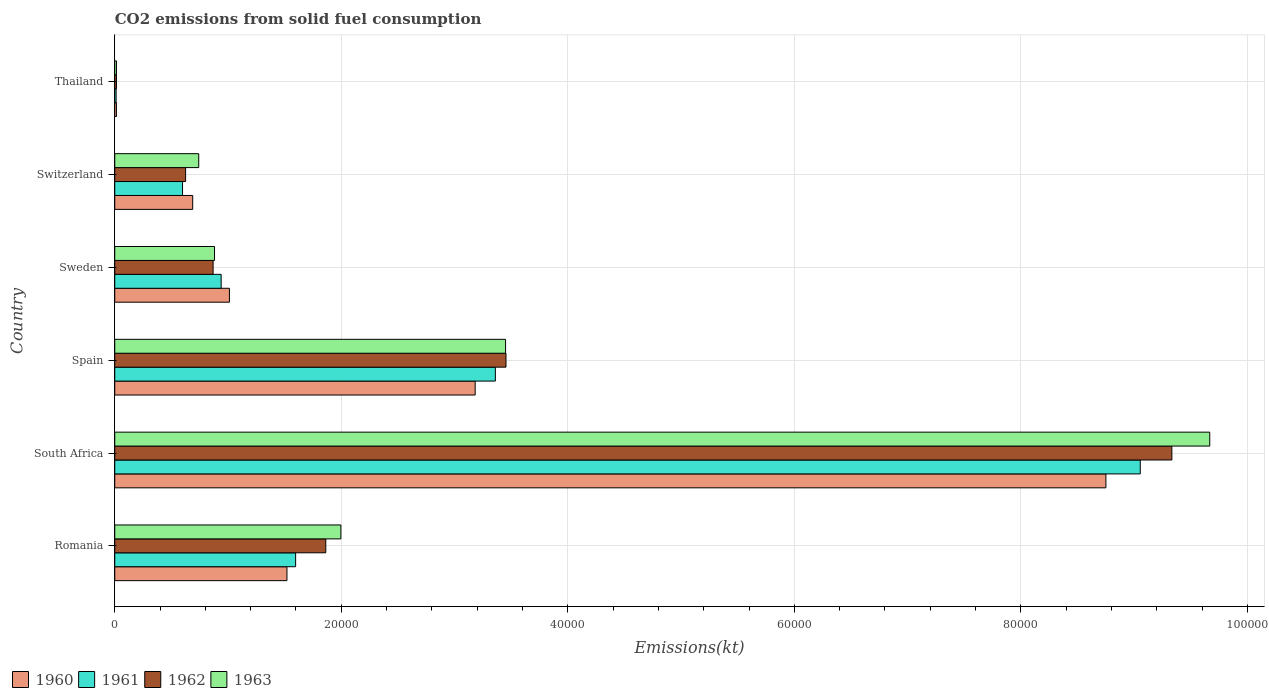How many different coloured bars are there?
Provide a short and direct response. 4. How many bars are there on the 3rd tick from the bottom?
Ensure brevity in your answer.  4. What is the label of the 5th group of bars from the top?
Offer a very short reply. South Africa. What is the amount of CO2 emitted in 1960 in South Africa?
Your response must be concise. 8.75e+04. Across all countries, what is the maximum amount of CO2 emitted in 1962?
Your response must be concise. 9.33e+04. Across all countries, what is the minimum amount of CO2 emitted in 1960?
Your answer should be very brief. 146.68. In which country was the amount of CO2 emitted in 1962 maximum?
Ensure brevity in your answer.  South Africa. In which country was the amount of CO2 emitted in 1960 minimum?
Your answer should be very brief. Thailand. What is the total amount of CO2 emitted in 1962 in the graph?
Your response must be concise. 1.62e+05. What is the difference between the amount of CO2 emitted in 1962 in Sweden and that in Switzerland?
Your response must be concise. 2427.55. What is the difference between the amount of CO2 emitted in 1960 in Romania and the amount of CO2 emitted in 1961 in Spain?
Give a very brief answer. -1.84e+04. What is the average amount of CO2 emitted in 1962 per country?
Provide a succinct answer. 2.69e+04. What is the difference between the amount of CO2 emitted in 1962 and amount of CO2 emitted in 1961 in Sweden?
Your answer should be compact. -711.4. In how many countries, is the amount of CO2 emitted in 1961 greater than 68000 kt?
Keep it short and to the point. 1. What is the ratio of the amount of CO2 emitted in 1961 in Romania to that in Spain?
Give a very brief answer. 0.48. Is the amount of CO2 emitted in 1963 in Sweden less than that in Switzerland?
Your answer should be compact. No. What is the difference between the highest and the second highest amount of CO2 emitted in 1960?
Ensure brevity in your answer.  5.57e+04. What is the difference between the highest and the lowest amount of CO2 emitted in 1963?
Make the answer very short. 9.65e+04. In how many countries, is the amount of CO2 emitted in 1961 greater than the average amount of CO2 emitted in 1961 taken over all countries?
Ensure brevity in your answer.  2. What does the 3rd bar from the top in Sweden represents?
Offer a very short reply. 1961. Is it the case that in every country, the sum of the amount of CO2 emitted in 1963 and amount of CO2 emitted in 1960 is greater than the amount of CO2 emitted in 1962?
Your answer should be very brief. Yes. What is the difference between two consecutive major ticks on the X-axis?
Provide a short and direct response. 2.00e+04. Are the values on the major ticks of X-axis written in scientific E-notation?
Give a very brief answer. No. How many legend labels are there?
Provide a succinct answer. 4. How are the legend labels stacked?
Your response must be concise. Horizontal. What is the title of the graph?
Offer a very short reply. CO2 emissions from solid fuel consumption. Does "2006" appear as one of the legend labels in the graph?
Your answer should be compact. No. What is the label or title of the X-axis?
Provide a succinct answer. Emissions(kt). What is the label or title of the Y-axis?
Make the answer very short. Country. What is the Emissions(kt) in 1960 in Romania?
Provide a short and direct response. 1.52e+04. What is the Emissions(kt) in 1961 in Romania?
Offer a terse response. 1.60e+04. What is the Emissions(kt) of 1962 in Romania?
Offer a very short reply. 1.86e+04. What is the Emissions(kt) of 1963 in Romania?
Provide a short and direct response. 2.00e+04. What is the Emissions(kt) in 1960 in South Africa?
Your response must be concise. 8.75e+04. What is the Emissions(kt) in 1961 in South Africa?
Offer a terse response. 9.05e+04. What is the Emissions(kt) in 1962 in South Africa?
Make the answer very short. 9.33e+04. What is the Emissions(kt) of 1963 in South Africa?
Provide a succinct answer. 9.67e+04. What is the Emissions(kt) of 1960 in Spain?
Your response must be concise. 3.18e+04. What is the Emissions(kt) in 1961 in Spain?
Keep it short and to the point. 3.36e+04. What is the Emissions(kt) of 1962 in Spain?
Offer a terse response. 3.45e+04. What is the Emissions(kt) in 1963 in Spain?
Your answer should be very brief. 3.45e+04. What is the Emissions(kt) in 1960 in Sweden?
Your answer should be very brief. 1.01e+04. What is the Emissions(kt) in 1961 in Sweden?
Provide a short and direct response. 9394.85. What is the Emissions(kt) in 1962 in Sweden?
Offer a very short reply. 8683.46. What is the Emissions(kt) of 1963 in Sweden?
Make the answer very short. 8808.13. What is the Emissions(kt) in 1960 in Switzerland?
Your response must be concise. 6882.96. What is the Emissions(kt) in 1961 in Switzerland?
Give a very brief answer. 5984.54. What is the Emissions(kt) in 1962 in Switzerland?
Offer a terse response. 6255.9. What is the Emissions(kt) in 1963 in Switzerland?
Provide a short and direct response. 7414.67. What is the Emissions(kt) of 1960 in Thailand?
Offer a very short reply. 146.68. What is the Emissions(kt) of 1961 in Thailand?
Your answer should be very brief. 121.01. What is the Emissions(kt) in 1962 in Thailand?
Provide a succinct answer. 150.35. What is the Emissions(kt) in 1963 in Thailand?
Provide a short and direct response. 150.35. Across all countries, what is the maximum Emissions(kt) in 1960?
Give a very brief answer. 8.75e+04. Across all countries, what is the maximum Emissions(kt) of 1961?
Give a very brief answer. 9.05e+04. Across all countries, what is the maximum Emissions(kt) in 1962?
Give a very brief answer. 9.33e+04. Across all countries, what is the maximum Emissions(kt) in 1963?
Keep it short and to the point. 9.67e+04. Across all countries, what is the minimum Emissions(kt) in 1960?
Give a very brief answer. 146.68. Across all countries, what is the minimum Emissions(kt) in 1961?
Offer a terse response. 121.01. Across all countries, what is the minimum Emissions(kt) of 1962?
Offer a very short reply. 150.35. Across all countries, what is the minimum Emissions(kt) in 1963?
Ensure brevity in your answer.  150.35. What is the total Emissions(kt) in 1960 in the graph?
Provide a succinct answer. 1.52e+05. What is the total Emissions(kt) in 1961 in the graph?
Keep it short and to the point. 1.56e+05. What is the total Emissions(kt) in 1962 in the graph?
Give a very brief answer. 1.62e+05. What is the total Emissions(kt) in 1963 in the graph?
Your answer should be very brief. 1.68e+05. What is the difference between the Emissions(kt) of 1960 in Romania and that in South Africa?
Provide a succinct answer. -7.23e+04. What is the difference between the Emissions(kt) in 1961 in Romania and that in South Africa?
Your answer should be very brief. -7.46e+04. What is the difference between the Emissions(kt) of 1962 in Romania and that in South Africa?
Offer a terse response. -7.47e+04. What is the difference between the Emissions(kt) of 1963 in Romania and that in South Africa?
Provide a short and direct response. -7.67e+04. What is the difference between the Emissions(kt) in 1960 in Romania and that in Spain?
Keep it short and to the point. -1.66e+04. What is the difference between the Emissions(kt) of 1961 in Romania and that in Spain?
Give a very brief answer. -1.76e+04. What is the difference between the Emissions(kt) in 1962 in Romania and that in Spain?
Provide a short and direct response. -1.59e+04. What is the difference between the Emissions(kt) of 1963 in Romania and that in Spain?
Provide a short and direct response. -1.45e+04. What is the difference between the Emissions(kt) of 1960 in Romania and that in Sweden?
Make the answer very short. 5078.8. What is the difference between the Emissions(kt) of 1961 in Romania and that in Sweden?
Your answer should be very brief. 6574.93. What is the difference between the Emissions(kt) of 1962 in Romania and that in Sweden?
Offer a very short reply. 9948.57. What is the difference between the Emissions(kt) in 1963 in Romania and that in Sweden?
Offer a very short reply. 1.12e+04. What is the difference between the Emissions(kt) of 1960 in Romania and that in Switzerland?
Ensure brevity in your answer.  8320.42. What is the difference between the Emissions(kt) of 1961 in Romania and that in Switzerland?
Make the answer very short. 9985.24. What is the difference between the Emissions(kt) in 1962 in Romania and that in Switzerland?
Give a very brief answer. 1.24e+04. What is the difference between the Emissions(kt) of 1963 in Romania and that in Switzerland?
Make the answer very short. 1.26e+04. What is the difference between the Emissions(kt) of 1960 in Romania and that in Thailand?
Your answer should be very brief. 1.51e+04. What is the difference between the Emissions(kt) of 1961 in Romania and that in Thailand?
Your answer should be compact. 1.58e+04. What is the difference between the Emissions(kt) of 1962 in Romania and that in Thailand?
Give a very brief answer. 1.85e+04. What is the difference between the Emissions(kt) of 1963 in Romania and that in Thailand?
Keep it short and to the point. 1.98e+04. What is the difference between the Emissions(kt) in 1960 in South Africa and that in Spain?
Your answer should be compact. 5.57e+04. What is the difference between the Emissions(kt) of 1961 in South Africa and that in Spain?
Your answer should be very brief. 5.69e+04. What is the difference between the Emissions(kt) in 1962 in South Africa and that in Spain?
Offer a terse response. 5.88e+04. What is the difference between the Emissions(kt) of 1963 in South Africa and that in Spain?
Your answer should be compact. 6.22e+04. What is the difference between the Emissions(kt) of 1960 in South Africa and that in Sweden?
Offer a terse response. 7.74e+04. What is the difference between the Emissions(kt) in 1961 in South Africa and that in Sweden?
Provide a succinct answer. 8.12e+04. What is the difference between the Emissions(kt) in 1962 in South Africa and that in Sweden?
Make the answer very short. 8.47e+04. What is the difference between the Emissions(kt) in 1963 in South Africa and that in Sweden?
Give a very brief answer. 8.79e+04. What is the difference between the Emissions(kt) in 1960 in South Africa and that in Switzerland?
Offer a very short reply. 8.06e+04. What is the difference between the Emissions(kt) in 1961 in South Africa and that in Switzerland?
Make the answer very short. 8.46e+04. What is the difference between the Emissions(kt) of 1962 in South Africa and that in Switzerland?
Give a very brief answer. 8.71e+04. What is the difference between the Emissions(kt) in 1963 in South Africa and that in Switzerland?
Keep it short and to the point. 8.93e+04. What is the difference between the Emissions(kt) in 1960 in South Africa and that in Thailand?
Offer a terse response. 8.74e+04. What is the difference between the Emissions(kt) of 1961 in South Africa and that in Thailand?
Your answer should be compact. 9.04e+04. What is the difference between the Emissions(kt) in 1962 in South Africa and that in Thailand?
Keep it short and to the point. 9.32e+04. What is the difference between the Emissions(kt) of 1963 in South Africa and that in Thailand?
Give a very brief answer. 9.65e+04. What is the difference between the Emissions(kt) in 1960 in Spain and that in Sweden?
Provide a short and direct response. 2.17e+04. What is the difference between the Emissions(kt) in 1961 in Spain and that in Sweden?
Make the answer very short. 2.42e+04. What is the difference between the Emissions(kt) of 1962 in Spain and that in Sweden?
Offer a terse response. 2.59e+04. What is the difference between the Emissions(kt) in 1963 in Spain and that in Sweden?
Make the answer very short. 2.57e+04. What is the difference between the Emissions(kt) in 1960 in Spain and that in Switzerland?
Offer a terse response. 2.49e+04. What is the difference between the Emissions(kt) in 1961 in Spain and that in Switzerland?
Ensure brevity in your answer.  2.76e+04. What is the difference between the Emissions(kt) in 1962 in Spain and that in Switzerland?
Your response must be concise. 2.83e+04. What is the difference between the Emissions(kt) in 1963 in Spain and that in Switzerland?
Your answer should be very brief. 2.71e+04. What is the difference between the Emissions(kt) of 1960 in Spain and that in Thailand?
Your answer should be very brief. 3.17e+04. What is the difference between the Emissions(kt) in 1961 in Spain and that in Thailand?
Provide a short and direct response. 3.35e+04. What is the difference between the Emissions(kt) of 1962 in Spain and that in Thailand?
Make the answer very short. 3.44e+04. What is the difference between the Emissions(kt) of 1963 in Spain and that in Thailand?
Provide a succinct answer. 3.44e+04. What is the difference between the Emissions(kt) of 1960 in Sweden and that in Switzerland?
Provide a succinct answer. 3241.63. What is the difference between the Emissions(kt) in 1961 in Sweden and that in Switzerland?
Your response must be concise. 3410.31. What is the difference between the Emissions(kt) of 1962 in Sweden and that in Switzerland?
Make the answer very short. 2427.55. What is the difference between the Emissions(kt) in 1963 in Sweden and that in Switzerland?
Provide a short and direct response. 1393.46. What is the difference between the Emissions(kt) of 1960 in Sweden and that in Thailand?
Provide a short and direct response. 9977.91. What is the difference between the Emissions(kt) of 1961 in Sweden and that in Thailand?
Keep it short and to the point. 9273.84. What is the difference between the Emissions(kt) of 1962 in Sweden and that in Thailand?
Give a very brief answer. 8533.11. What is the difference between the Emissions(kt) of 1963 in Sweden and that in Thailand?
Offer a very short reply. 8657.79. What is the difference between the Emissions(kt) of 1960 in Switzerland and that in Thailand?
Your response must be concise. 6736.28. What is the difference between the Emissions(kt) of 1961 in Switzerland and that in Thailand?
Your answer should be very brief. 5863.53. What is the difference between the Emissions(kt) in 1962 in Switzerland and that in Thailand?
Ensure brevity in your answer.  6105.56. What is the difference between the Emissions(kt) of 1963 in Switzerland and that in Thailand?
Provide a short and direct response. 7264.33. What is the difference between the Emissions(kt) in 1960 in Romania and the Emissions(kt) in 1961 in South Africa?
Provide a short and direct response. -7.53e+04. What is the difference between the Emissions(kt) in 1960 in Romania and the Emissions(kt) in 1962 in South Africa?
Your answer should be compact. -7.81e+04. What is the difference between the Emissions(kt) in 1960 in Romania and the Emissions(kt) in 1963 in South Africa?
Ensure brevity in your answer.  -8.15e+04. What is the difference between the Emissions(kt) in 1961 in Romania and the Emissions(kt) in 1962 in South Africa?
Your answer should be very brief. -7.74e+04. What is the difference between the Emissions(kt) in 1961 in Romania and the Emissions(kt) in 1963 in South Africa?
Keep it short and to the point. -8.07e+04. What is the difference between the Emissions(kt) in 1962 in Romania and the Emissions(kt) in 1963 in South Africa?
Provide a succinct answer. -7.80e+04. What is the difference between the Emissions(kt) of 1960 in Romania and the Emissions(kt) of 1961 in Spain?
Offer a very short reply. -1.84e+04. What is the difference between the Emissions(kt) of 1960 in Romania and the Emissions(kt) of 1962 in Spain?
Provide a short and direct response. -1.93e+04. What is the difference between the Emissions(kt) of 1960 in Romania and the Emissions(kt) of 1963 in Spain?
Provide a short and direct response. -1.93e+04. What is the difference between the Emissions(kt) of 1961 in Romania and the Emissions(kt) of 1962 in Spain?
Provide a succinct answer. -1.86e+04. What is the difference between the Emissions(kt) in 1961 in Romania and the Emissions(kt) in 1963 in Spain?
Provide a succinct answer. -1.85e+04. What is the difference between the Emissions(kt) of 1962 in Romania and the Emissions(kt) of 1963 in Spain?
Your answer should be very brief. -1.59e+04. What is the difference between the Emissions(kt) of 1960 in Romania and the Emissions(kt) of 1961 in Sweden?
Offer a very short reply. 5808.53. What is the difference between the Emissions(kt) of 1960 in Romania and the Emissions(kt) of 1962 in Sweden?
Your answer should be compact. 6519.93. What is the difference between the Emissions(kt) in 1960 in Romania and the Emissions(kt) in 1963 in Sweden?
Your answer should be very brief. 6395.25. What is the difference between the Emissions(kt) in 1961 in Romania and the Emissions(kt) in 1962 in Sweden?
Ensure brevity in your answer.  7286.33. What is the difference between the Emissions(kt) of 1961 in Romania and the Emissions(kt) of 1963 in Sweden?
Your response must be concise. 7161.65. What is the difference between the Emissions(kt) in 1962 in Romania and the Emissions(kt) in 1963 in Sweden?
Offer a very short reply. 9823.89. What is the difference between the Emissions(kt) in 1960 in Romania and the Emissions(kt) in 1961 in Switzerland?
Your answer should be very brief. 9218.84. What is the difference between the Emissions(kt) in 1960 in Romania and the Emissions(kt) in 1962 in Switzerland?
Provide a succinct answer. 8947.48. What is the difference between the Emissions(kt) in 1960 in Romania and the Emissions(kt) in 1963 in Switzerland?
Keep it short and to the point. 7788.71. What is the difference between the Emissions(kt) in 1961 in Romania and the Emissions(kt) in 1962 in Switzerland?
Your answer should be very brief. 9713.88. What is the difference between the Emissions(kt) in 1961 in Romania and the Emissions(kt) in 1963 in Switzerland?
Provide a succinct answer. 8555.11. What is the difference between the Emissions(kt) of 1962 in Romania and the Emissions(kt) of 1963 in Switzerland?
Provide a succinct answer. 1.12e+04. What is the difference between the Emissions(kt) of 1960 in Romania and the Emissions(kt) of 1961 in Thailand?
Give a very brief answer. 1.51e+04. What is the difference between the Emissions(kt) in 1960 in Romania and the Emissions(kt) in 1962 in Thailand?
Provide a succinct answer. 1.51e+04. What is the difference between the Emissions(kt) in 1960 in Romania and the Emissions(kt) in 1963 in Thailand?
Give a very brief answer. 1.51e+04. What is the difference between the Emissions(kt) of 1961 in Romania and the Emissions(kt) of 1962 in Thailand?
Your response must be concise. 1.58e+04. What is the difference between the Emissions(kt) of 1961 in Romania and the Emissions(kt) of 1963 in Thailand?
Make the answer very short. 1.58e+04. What is the difference between the Emissions(kt) of 1962 in Romania and the Emissions(kt) of 1963 in Thailand?
Give a very brief answer. 1.85e+04. What is the difference between the Emissions(kt) of 1960 in South Africa and the Emissions(kt) of 1961 in Spain?
Your answer should be very brief. 5.39e+04. What is the difference between the Emissions(kt) in 1960 in South Africa and the Emissions(kt) in 1962 in Spain?
Keep it short and to the point. 5.30e+04. What is the difference between the Emissions(kt) of 1960 in South Africa and the Emissions(kt) of 1963 in Spain?
Your response must be concise. 5.30e+04. What is the difference between the Emissions(kt) of 1961 in South Africa and the Emissions(kt) of 1962 in Spain?
Offer a very short reply. 5.60e+04. What is the difference between the Emissions(kt) of 1961 in South Africa and the Emissions(kt) of 1963 in Spain?
Give a very brief answer. 5.60e+04. What is the difference between the Emissions(kt) of 1962 in South Africa and the Emissions(kt) of 1963 in Spain?
Offer a terse response. 5.88e+04. What is the difference between the Emissions(kt) of 1960 in South Africa and the Emissions(kt) of 1961 in Sweden?
Offer a terse response. 7.81e+04. What is the difference between the Emissions(kt) of 1960 in South Africa and the Emissions(kt) of 1962 in Sweden?
Ensure brevity in your answer.  7.88e+04. What is the difference between the Emissions(kt) of 1960 in South Africa and the Emissions(kt) of 1963 in Sweden?
Your answer should be compact. 7.87e+04. What is the difference between the Emissions(kt) of 1961 in South Africa and the Emissions(kt) of 1962 in Sweden?
Your answer should be compact. 8.19e+04. What is the difference between the Emissions(kt) in 1961 in South Africa and the Emissions(kt) in 1963 in Sweden?
Keep it short and to the point. 8.17e+04. What is the difference between the Emissions(kt) in 1962 in South Africa and the Emissions(kt) in 1963 in Sweden?
Offer a very short reply. 8.45e+04. What is the difference between the Emissions(kt) in 1960 in South Africa and the Emissions(kt) in 1961 in Switzerland?
Provide a short and direct response. 8.15e+04. What is the difference between the Emissions(kt) in 1960 in South Africa and the Emissions(kt) in 1962 in Switzerland?
Your response must be concise. 8.13e+04. What is the difference between the Emissions(kt) in 1960 in South Africa and the Emissions(kt) in 1963 in Switzerland?
Ensure brevity in your answer.  8.01e+04. What is the difference between the Emissions(kt) in 1961 in South Africa and the Emissions(kt) in 1962 in Switzerland?
Give a very brief answer. 8.43e+04. What is the difference between the Emissions(kt) in 1961 in South Africa and the Emissions(kt) in 1963 in Switzerland?
Your answer should be very brief. 8.31e+04. What is the difference between the Emissions(kt) in 1962 in South Africa and the Emissions(kt) in 1963 in Switzerland?
Offer a terse response. 8.59e+04. What is the difference between the Emissions(kt) of 1960 in South Africa and the Emissions(kt) of 1961 in Thailand?
Offer a very short reply. 8.74e+04. What is the difference between the Emissions(kt) of 1960 in South Africa and the Emissions(kt) of 1962 in Thailand?
Offer a terse response. 8.74e+04. What is the difference between the Emissions(kt) of 1960 in South Africa and the Emissions(kt) of 1963 in Thailand?
Provide a succinct answer. 8.74e+04. What is the difference between the Emissions(kt) in 1961 in South Africa and the Emissions(kt) in 1962 in Thailand?
Provide a short and direct response. 9.04e+04. What is the difference between the Emissions(kt) in 1961 in South Africa and the Emissions(kt) in 1963 in Thailand?
Ensure brevity in your answer.  9.04e+04. What is the difference between the Emissions(kt) of 1962 in South Africa and the Emissions(kt) of 1963 in Thailand?
Ensure brevity in your answer.  9.32e+04. What is the difference between the Emissions(kt) of 1960 in Spain and the Emissions(kt) of 1961 in Sweden?
Your response must be concise. 2.24e+04. What is the difference between the Emissions(kt) of 1960 in Spain and the Emissions(kt) of 1962 in Sweden?
Offer a very short reply. 2.31e+04. What is the difference between the Emissions(kt) in 1960 in Spain and the Emissions(kt) in 1963 in Sweden?
Ensure brevity in your answer.  2.30e+04. What is the difference between the Emissions(kt) of 1961 in Spain and the Emissions(kt) of 1962 in Sweden?
Your answer should be compact. 2.49e+04. What is the difference between the Emissions(kt) in 1961 in Spain and the Emissions(kt) in 1963 in Sweden?
Offer a very short reply. 2.48e+04. What is the difference between the Emissions(kt) of 1962 in Spain and the Emissions(kt) of 1963 in Sweden?
Keep it short and to the point. 2.57e+04. What is the difference between the Emissions(kt) of 1960 in Spain and the Emissions(kt) of 1961 in Switzerland?
Provide a short and direct response. 2.58e+04. What is the difference between the Emissions(kt) in 1960 in Spain and the Emissions(kt) in 1962 in Switzerland?
Make the answer very short. 2.56e+04. What is the difference between the Emissions(kt) of 1960 in Spain and the Emissions(kt) of 1963 in Switzerland?
Provide a short and direct response. 2.44e+04. What is the difference between the Emissions(kt) of 1961 in Spain and the Emissions(kt) of 1962 in Switzerland?
Offer a very short reply. 2.73e+04. What is the difference between the Emissions(kt) of 1961 in Spain and the Emissions(kt) of 1963 in Switzerland?
Offer a very short reply. 2.62e+04. What is the difference between the Emissions(kt) in 1962 in Spain and the Emissions(kt) in 1963 in Switzerland?
Ensure brevity in your answer.  2.71e+04. What is the difference between the Emissions(kt) in 1960 in Spain and the Emissions(kt) in 1961 in Thailand?
Your answer should be very brief. 3.17e+04. What is the difference between the Emissions(kt) in 1960 in Spain and the Emissions(kt) in 1962 in Thailand?
Make the answer very short. 3.17e+04. What is the difference between the Emissions(kt) of 1960 in Spain and the Emissions(kt) of 1963 in Thailand?
Provide a succinct answer. 3.17e+04. What is the difference between the Emissions(kt) in 1961 in Spain and the Emissions(kt) in 1962 in Thailand?
Offer a terse response. 3.35e+04. What is the difference between the Emissions(kt) in 1961 in Spain and the Emissions(kt) in 1963 in Thailand?
Provide a short and direct response. 3.35e+04. What is the difference between the Emissions(kt) of 1962 in Spain and the Emissions(kt) of 1963 in Thailand?
Give a very brief answer. 3.44e+04. What is the difference between the Emissions(kt) in 1960 in Sweden and the Emissions(kt) in 1961 in Switzerland?
Offer a very short reply. 4140.04. What is the difference between the Emissions(kt) in 1960 in Sweden and the Emissions(kt) in 1962 in Switzerland?
Make the answer very short. 3868.68. What is the difference between the Emissions(kt) of 1960 in Sweden and the Emissions(kt) of 1963 in Switzerland?
Offer a very short reply. 2709.91. What is the difference between the Emissions(kt) of 1961 in Sweden and the Emissions(kt) of 1962 in Switzerland?
Ensure brevity in your answer.  3138.95. What is the difference between the Emissions(kt) of 1961 in Sweden and the Emissions(kt) of 1963 in Switzerland?
Provide a short and direct response. 1980.18. What is the difference between the Emissions(kt) in 1962 in Sweden and the Emissions(kt) in 1963 in Switzerland?
Offer a terse response. 1268.78. What is the difference between the Emissions(kt) in 1960 in Sweden and the Emissions(kt) in 1961 in Thailand?
Make the answer very short. 1.00e+04. What is the difference between the Emissions(kt) of 1960 in Sweden and the Emissions(kt) of 1962 in Thailand?
Keep it short and to the point. 9974.24. What is the difference between the Emissions(kt) of 1960 in Sweden and the Emissions(kt) of 1963 in Thailand?
Your response must be concise. 9974.24. What is the difference between the Emissions(kt) in 1961 in Sweden and the Emissions(kt) in 1962 in Thailand?
Offer a terse response. 9244.51. What is the difference between the Emissions(kt) of 1961 in Sweden and the Emissions(kt) of 1963 in Thailand?
Offer a terse response. 9244.51. What is the difference between the Emissions(kt) in 1962 in Sweden and the Emissions(kt) in 1963 in Thailand?
Your answer should be very brief. 8533.11. What is the difference between the Emissions(kt) of 1960 in Switzerland and the Emissions(kt) of 1961 in Thailand?
Provide a short and direct response. 6761.95. What is the difference between the Emissions(kt) of 1960 in Switzerland and the Emissions(kt) of 1962 in Thailand?
Offer a very short reply. 6732.61. What is the difference between the Emissions(kt) of 1960 in Switzerland and the Emissions(kt) of 1963 in Thailand?
Ensure brevity in your answer.  6732.61. What is the difference between the Emissions(kt) in 1961 in Switzerland and the Emissions(kt) in 1962 in Thailand?
Offer a very short reply. 5834.2. What is the difference between the Emissions(kt) in 1961 in Switzerland and the Emissions(kt) in 1963 in Thailand?
Offer a terse response. 5834.2. What is the difference between the Emissions(kt) in 1962 in Switzerland and the Emissions(kt) in 1963 in Thailand?
Your answer should be compact. 6105.56. What is the average Emissions(kt) of 1960 per country?
Your answer should be compact. 2.53e+04. What is the average Emissions(kt) in 1961 per country?
Make the answer very short. 2.59e+04. What is the average Emissions(kt) of 1962 per country?
Provide a short and direct response. 2.69e+04. What is the average Emissions(kt) of 1963 per country?
Make the answer very short. 2.79e+04. What is the difference between the Emissions(kt) in 1960 and Emissions(kt) in 1961 in Romania?
Ensure brevity in your answer.  -766.4. What is the difference between the Emissions(kt) in 1960 and Emissions(kt) in 1962 in Romania?
Make the answer very short. -3428.64. What is the difference between the Emissions(kt) in 1960 and Emissions(kt) in 1963 in Romania?
Your answer should be compact. -4763.43. What is the difference between the Emissions(kt) of 1961 and Emissions(kt) of 1962 in Romania?
Offer a terse response. -2662.24. What is the difference between the Emissions(kt) in 1961 and Emissions(kt) in 1963 in Romania?
Your answer should be very brief. -3997.03. What is the difference between the Emissions(kt) of 1962 and Emissions(kt) of 1963 in Romania?
Your answer should be compact. -1334.79. What is the difference between the Emissions(kt) in 1960 and Emissions(kt) in 1961 in South Africa?
Your response must be concise. -3032.61. What is the difference between the Emissions(kt) of 1960 and Emissions(kt) of 1962 in South Africa?
Make the answer very short. -5823.2. What is the difference between the Emissions(kt) of 1960 and Emissions(kt) of 1963 in South Africa?
Your answer should be very brief. -9167.5. What is the difference between the Emissions(kt) of 1961 and Emissions(kt) of 1962 in South Africa?
Give a very brief answer. -2790.59. What is the difference between the Emissions(kt) of 1961 and Emissions(kt) of 1963 in South Africa?
Give a very brief answer. -6134.89. What is the difference between the Emissions(kt) of 1962 and Emissions(kt) of 1963 in South Africa?
Provide a succinct answer. -3344.3. What is the difference between the Emissions(kt) of 1960 and Emissions(kt) of 1961 in Spain?
Give a very brief answer. -1782.16. What is the difference between the Emissions(kt) of 1960 and Emissions(kt) of 1962 in Spain?
Keep it short and to the point. -2720.91. What is the difference between the Emissions(kt) of 1960 and Emissions(kt) of 1963 in Spain?
Give a very brief answer. -2684.24. What is the difference between the Emissions(kt) in 1961 and Emissions(kt) in 1962 in Spain?
Offer a very short reply. -938.75. What is the difference between the Emissions(kt) in 1961 and Emissions(kt) in 1963 in Spain?
Provide a short and direct response. -902.08. What is the difference between the Emissions(kt) of 1962 and Emissions(kt) of 1963 in Spain?
Provide a succinct answer. 36.67. What is the difference between the Emissions(kt) of 1960 and Emissions(kt) of 1961 in Sweden?
Offer a terse response. 729.73. What is the difference between the Emissions(kt) in 1960 and Emissions(kt) in 1962 in Sweden?
Offer a very short reply. 1441.13. What is the difference between the Emissions(kt) in 1960 and Emissions(kt) in 1963 in Sweden?
Ensure brevity in your answer.  1316.45. What is the difference between the Emissions(kt) of 1961 and Emissions(kt) of 1962 in Sweden?
Your answer should be compact. 711.4. What is the difference between the Emissions(kt) in 1961 and Emissions(kt) in 1963 in Sweden?
Ensure brevity in your answer.  586.72. What is the difference between the Emissions(kt) in 1962 and Emissions(kt) in 1963 in Sweden?
Your answer should be compact. -124.68. What is the difference between the Emissions(kt) in 1960 and Emissions(kt) in 1961 in Switzerland?
Give a very brief answer. 898.41. What is the difference between the Emissions(kt) in 1960 and Emissions(kt) in 1962 in Switzerland?
Ensure brevity in your answer.  627.06. What is the difference between the Emissions(kt) of 1960 and Emissions(kt) of 1963 in Switzerland?
Your answer should be compact. -531.72. What is the difference between the Emissions(kt) of 1961 and Emissions(kt) of 1962 in Switzerland?
Provide a short and direct response. -271.36. What is the difference between the Emissions(kt) in 1961 and Emissions(kt) in 1963 in Switzerland?
Provide a succinct answer. -1430.13. What is the difference between the Emissions(kt) of 1962 and Emissions(kt) of 1963 in Switzerland?
Your response must be concise. -1158.77. What is the difference between the Emissions(kt) of 1960 and Emissions(kt) of 1961 in Thailand?
Offer a terse response. 25.67. What is the difference between the Emissions(kt) in 1960 and Emissions(kt) in 1962 in Thailand?
Provide a succinct answer. -3.67. What is the difference between the Emissions(kt) in 1960 and Emissions(kt) in 1963 in Thailand?
Offer a terse response. -3.67. What is the difference between the Emissions(kt) of 1961 and Emissions(kt) of 1962 in Thailand?
Offer a very short reply. -29.34. What is the difference between the Emissions(kt) of 1961 and Emissions(kt) of 1963 in Thailand?
Your answer should be compact. -29.34. What is the difference between the Emissions(kt) in 1962 and Emissions(kt) in 1963 in Thailand?
Provide a short and direct response. 0. What is the ratio of the Emissions(kt) of 1960 in Romania to that in South Africa?
Provide a succinct answer. 0.17. What is the ratio of the Emissions(kt) in 1961 in Romania to that in South Africa?
Offer a terse response. 0.18. What is the ratio of the Emissions(kt) of 1962 in Romania to that in South Africa?
Offer a very short reply. 0.2. What is the ratio of the Emissions(kt) of 1963 in Romania to that in South Africa?
Your response must be concise. 0.21. What is the ratio of the Emissions(kt) in 1960 in Romania to that in Spain?
Provide a short and direct response. 0.48. What is the ratio of the Emissions(kt) of 1961 in Romania to that in Spain?
Give a very brief answer. 0.48. What is the ratio of the Emissions(kt) of 1962 in Romania to that in Spain?
Give a very brief answer. 0.54. What is the ratio of the Emissions(kt) of 1963 in Romania to that in Spain?
Your answer should be very brief. 0.58. What is the ratio of the Emissions(kt) in 1960 in Romania to that in Sweden?
Your answer should be very brief. 1.5. What is the ratio of the Emissions(kt) in 1961 in Romania to that in Sweden?
Make the answer very short. 1.7. What is the ratio of the Emissions(kt) of 1962 in Romania to that in Sweden?
Provide a short and direct response. 2.15. What is the ratio of the Emissions(kt) in 1963 in Romania to that in Sweden?
Offer a terse response. 2.27. What is the ratio of the Emissions(kt) of 1960 in Romania to that in Switzerland?
Your response must be concise. 2.21. What is the ratio of the Emissions(kt) in 1961 in Romania to that in Switzerland?
Your answer should be very brief. 2.67. What is the ratio of the Emissions(kt) of 1962 in Romania to that in Switzerland?
Provide a succinct answer. 2.98. What is the ratio of the Emissions(kt) in 1963 in Romania to that in Switzerland?
Give a very brief answer. 2.69. What is the ratio of the Emissions(kt) in 1960 in Romania to that in Thailand?
Your response must be concise. 103.65. What is the ratio of the Emissions(kt) in 1961 in Romania to that in Thailand?
Make the answer very short. 131.97. What is the ratio of the Emissions(kt) in 1962 in Romania to that in Thailand?
Offer a very short reply. 123.93. What is the ratio of the Emissions(kt) in 1963 in Romania to that in Thailand?
Your answer should be compact. 132.8. What is the ratio of the Emissions(kt) in 1960 in South Africa to that in Spain?
Keep it short and to the point. 2.75. What is the ratio of the Emissions(kt) of 1961 in South Africa to that in Spain?
Offer a very short reply. 2.69. What is the ratio of the Emissions(kt) of 1962 in South Africa to that in Spain?
Give a very brief answer. 2.7. What is the ratio of the Emissions(kt) in 1963 in South Africa to that in Spain?
Your response must be concise. 2.8. What is the ratio of the Emissions(kt) of 1960 in South Africa to that in Sweden?
Give a very brief answer. 8.64. What is the ratio of the Emissions(kt) in 1961 in South Africa to that in Sweden?
Your response must be concise. 9.64. What is the ratio of the Emissions(kt) in 1962 in South Africa to that in Sweden?
Ensure brevity in your answer.  10.75. What is the ratio of the Emissions(kt) of 1963 in South Africa to that in Sweden?
Ensure brevity in your answer.  10.98. What is the ratio of the Emissions(kt) of 1960 in South Africa to that in Switzerland?
Provide a short and direct response. 12.71. What is the ratio of the Emissions(kt) in 1961 in South Africa to that in Switzerland?
Your response must be concise. 15.13. What is the ratio of the Emissions(kt) in 1962 in South Africa to that in Switzerland?
Your answer should be compact. 14.92. What is the ratio of the Emissions(kt) in 1963 in South Africa to that in Switzerland?
Your answer should be very brief. 13.04. What is the ratio of the Emissions(kt) in 1960 in South Africa to that in Thailand?
Your answer should be very brief. 596.62. What is the ratio of the Emissions(kt) in 1961 in South Africa to that in Thailand?
Ensure brevity in your answer.  748.24. What is the ratio of the Emissions(kt) in 1962 in South Africa to that in Thailand?
Your answer should be compact. 620.8. What is the ratio of the Emissions(kt) in 1963 in South Africa to that in Thailand?
Offer a very short reply. 643.05. What is the ratio of the Emissions(kt) of 1960 in Spain to that in Sweden?
Provide a succinct answer. 3.14. What is the ratio of the Emissions(kt) of 1961 in Spain to that in Sweden?
Provide a succinct answer. 3.58. What is the ratio of the Emissions(kt) in 1962 in Spain to that in Sweden?
Offer a very short reply. 3.98. What is the ratio of the Emissions(kt) of 1963 in Spain to that in Sweden?
Provide a succinct answer. 3.92. What is the ratio of the Emissions(kt) of 1960 in Spain to that in Switzerland?
Make the answer very short. 4.62. What is the ratio of the Emissions(kt) of 1961 in Spain to that in Switzerland?
Make the answer very short. 5.62. What is the ratio of the Emissions(kt) in 1962 in Spain to that in Switzerland?
Offer a terse response. 5.52. What is the ratio of the Emissions(kt) of 1963 in Spain to that in Switzerland?
Provide a short and direct response. 4.65. What is the ratio of the Emissions(kt) in 1960 in Spain to that in Thailand?
Offer a terse response. 216.95. What is the ratio of the Emissions(kt) of 1961 in Spain to that in Thailand?
Keep it short and to the point. 277.7. What is the ratio of the Emissions(kt) of 1962 in Spain to that in Thailand?
Your answer should be very brief. 229.76. What is the ratio of the Emissions(kt) in 1963 in Spain to that in Thailand?
Provide a succinct answer. 229.51. What is the ratio of the Emissions(kt) in 1960 in Sweden to that in Switzerland?
Your answer should be very brief. 1.47. What is the ratio of the Emissions(kt) in 1961 in Sweden to that in Switzerland?
Your response must be concise. 1.57. What is the ratio of the Emissions(kt) of 1962 in Sweden to that in Switzerland?
Ensure brevity in your answer.  1.39. What is the ratio of the Emissions(kt) of 1963 in Sweden to that in Switzerland?
Ensure brevity in your answer.  1.19. What is the ratio of the Emissions(kt) of 1960 in Sweden to that in Thailand?
Give a very brief answer. 69.03. What is the ratio of the Emissions(kt) of 1961 in Sweden to that in Thailand?
Keep it short and to the point. 77.64. What is the ratio of the Emissions(kt) in 1962 in Sweden to that in Thailand?
Offer a terse response. 57.76. What is the ratio of the Emissions(kt) in 1963 in Sweden to that in Thailand?
Your answer should be compact. 58.59. What is the ratio of the Emissions(kt) in 1960 in Switzerland to that in Thailand?
Make the answer very short. 46.92. What is the ratio of the Emissions(kt) in 1961 in Switzerland to that in Thailand?
Your answer should be compact. 49.45. What is the ratio of the Emissions(kt) in 1962 in Switzerland to that in Thailand?
Provide a short and direct response. 41.61. What is the ratio of the Emissions(kt) of 1963 in Switzerland to that in Thailand?
Provide a succinct answer. 49.32. What is the difference between the highest and the second highest Emissions(kt) in 1960?
Provide a succinct answer. 5.57e+04. What is the difference between the highest and the second highest Emissions(kt) in 1961?
Offer a very short reply. 5.69e+04. What is the difference between the highest and the second highest Emissions(kt) in 1962?
Offer a very short reply. 5.88e+04. What is the difference between the highest and the second highest Emissions(kt) in 1963?
Your answer should be compact. 6.22e+04. What is the difference between the highest and the lowest Emissions(kt) in 1960?
Your answer should be compact. 8.74e+04. What is the difference between the highest and the lowest Emissions(kt) of 1961?
Ensure brevity in your answer.  9.04e+04. What is the difference between the highest and the lowest Emissions(kt) of 1962?
Your answer should be very brief. 9.32e+04. What is the difference between the highest and the lowest Emissions(kt) in 1963?
Keep it short and to the point. 9.65e+04. 